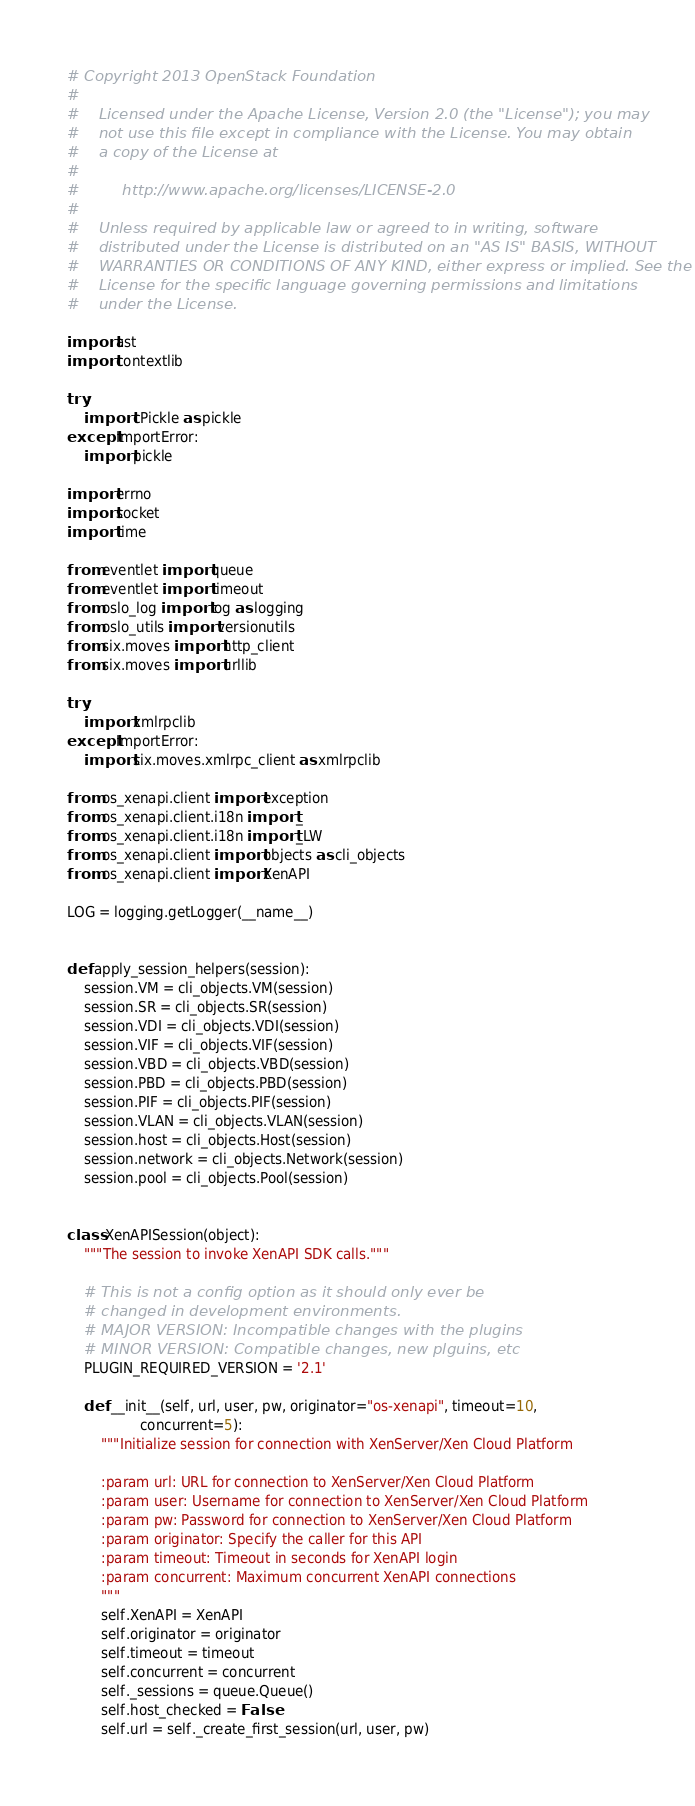<code> <loc_0><loc_0><loc_500><loc_500><_Python_># Copyright 2013 OpenStack Foundation
#
#    Licensed under the Apache License, Version 2.0 (the "License"); you may
#    not use this file except in compliance with the License. You may obtain
#    a copy of the License at
#
#         http://www.apache.org/licenses/LICENSE-2.0
#
#    Unless required by applicable law or agreed to in writing, software
#    distributed under the License is distributed on an "AS IS" BASIS, WITHOUT
#    WARRANTIES OR CONDITIONS OF ANY KIND, either express or implied. See the
#    License for the specific language governing permissions and limitations
#    under the License.

import ast
import contextlib

try:
    import cPickle as pickle
except ImportError:
    import pickle

import errno
import socket
import time

from eventlet import queue
from eventlet import timeout
from oslo_log import log as logging
from oslo_utils import versionutils
from six.moves import http_client
from six.moves import urllib

try:
    import xmlrpclib
except ImportError:
    import six.moves.xmlrpc_client as xmlrpclib

from os_xenapi.client import exception
from os_xenapi.client.i18n import _
from os_xenapi.client.i18n import _LW
from os_xenapi.client import objects as cli_objects
from os_xenapi.client import XenAPI

LOG = logging.getLogger(__name__)


def apply_session_helpers(session):
    session.VM = cli_objects.VM(session)
    session.SR = cli_objects.SR(session)
    session.VDI = cli_objects.VDI(session)
    session.VIF = cli_objects.VIF(session)
    session.VBD = cli_objects.VBD(session)
    session.PBD = cli_objects.PBD(session)
    session.PIF = cli_objects.PIF(session)
    session.VLAN = cli_objects.VLAN(session)
    session.host = cli_objects.Host(session)
    session.network = cli_objects.Network(session)
    session.pool = cli_objects.Pool(session)


class XenAPISession(object):
    """The session to invoke XenAPI SDK calls."""

    # This is not a config option as it should only ever be
    # changed in development environments.
    # MAJOR VERSION: Incompatible changes with the plugins
    # MINOR VERSION: Compatible changes, new plguins, etc
    PLUGIN_REQUIRED_VERSION = '2.1'

    def __init__(self, url, user, pw, originator="os-xenapi", timeout=10,
                 concurrent=5):
        """Initialize session for connection with XenServer/Xen Cloud Platform

        :param url: URL for connection to XenServer/Xen Cloud Platform
        :param user: Username for connection to XenServer/Xen Cloud Platform
        :param pw: Password for connection to XenServer/Xen Cloud Platform
        :param originator: Specify the caller for this API
        :param timeout: Timeout in seconds for XenAPI login
        :param concurrent: Maximum concurrent XenAPI connections
        """
        self.XenAPI = XenAPI
        self.originator = originator
        self.timeout = timeout
        self.concurrent = concurrent
        self._sessions = queue.Queue()
        self.host_checked = False
        self.url = self._create_first_session(url, user, pw)</code> 